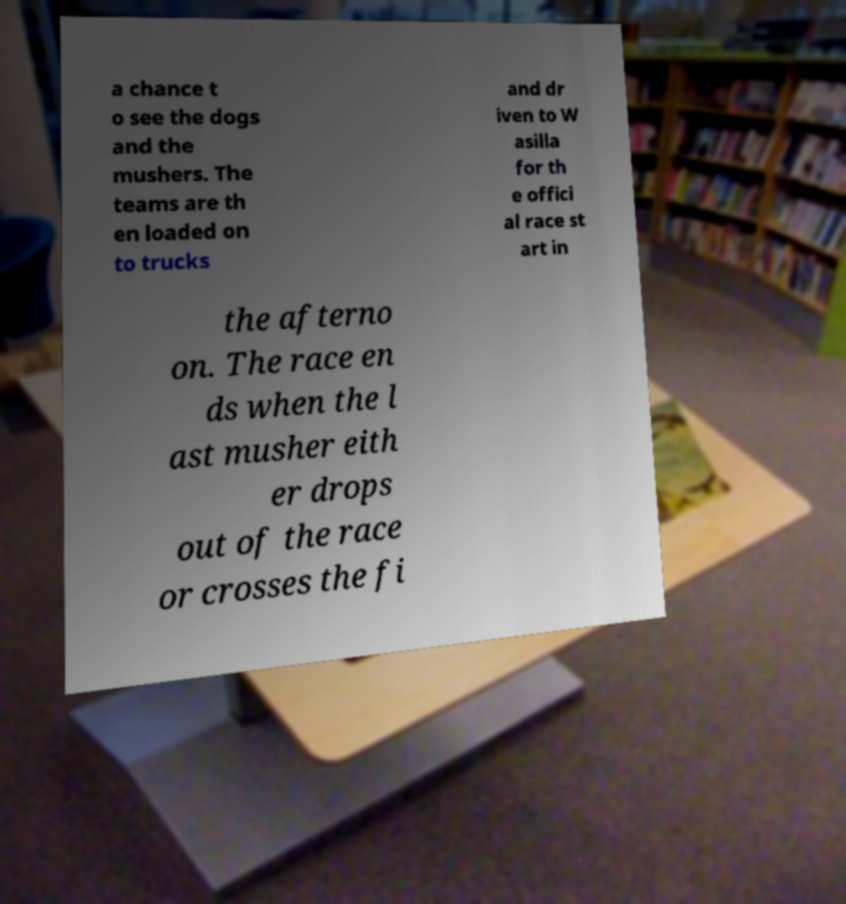Can you accurately transcribe the text from the provided image for me? a chance t o see the dogs and the mushers. The teams are th en loaded on to trucks and dr iven to W asilla for th e offici al race st art in the afterno on. The race en ds when the l ast musher eith er drops out of the race or crosses the fi 